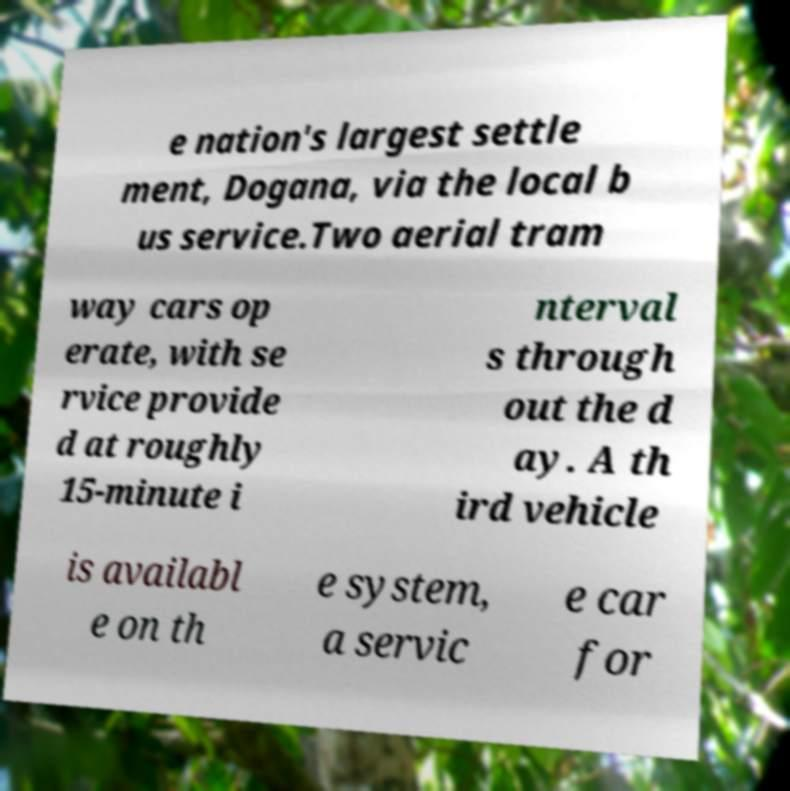For documentation purposes, I need the text within this image transcribed. Could you provide that? e nation's largest settle ment, Dogana, via the local b us service.Two aerial tram way cars op erate, with se rvice provide d at roughly 15-minute i nterval s through out the d ay. A th ird vehicle is availabl e on th e system, a servic e car for 